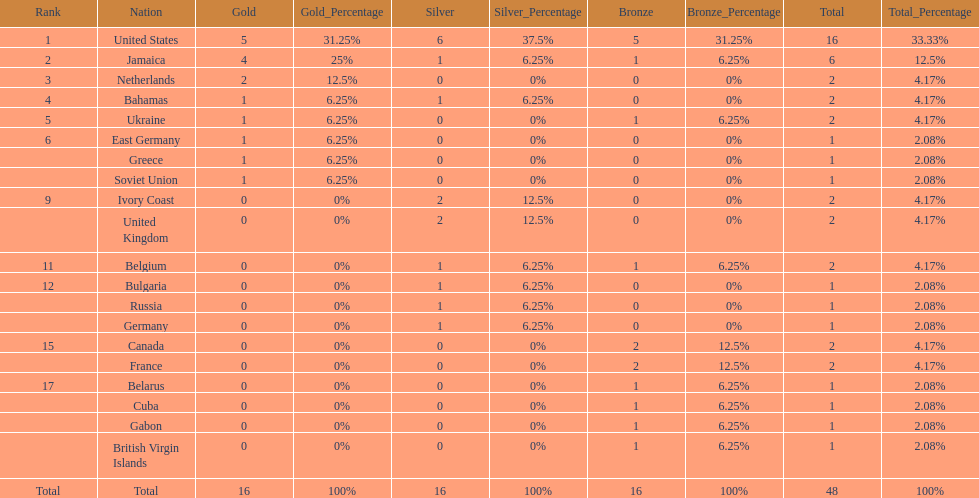What is the average number of gold medals won by the top 5 nations? 2.6. 